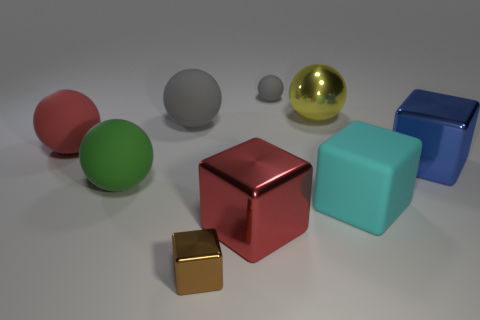Are there an equal number of gray rubber spheres that are in front of the small gray matte thing and large red things that are on the right side of the large yellow thing?
Your answer should be very brief. No. What number of red things are there?
Provide a short and direct response. 2. Is the number of objects to the right of the red sphere greater than the number of brown balls?
Offer a very short reply. Yes. What material is the large sphere in front of the large blue metal thing?
Provide a succinct answer. Rubber. What color is the metallic object that is the same shape as the big gray matte object?
Provide a succinct answer. Yellow. How many large metal balls have the same color as the tiny metallic object?
Make the answer very short. 0. Does the object left of the big green sphere have the same size as the gray sphere left of the tiny matte ball?
Your response must be concise. Yes. Is the size of the yellow object the same as the rubber thing that is behind the big yellow sphere?
Your answer should be very brief. No. What is the size of the brown cube?
Your answer should be compact. Small. What is the color of the cube that is the same material as the big green ball?
Give a very brief answer. Cyan. 